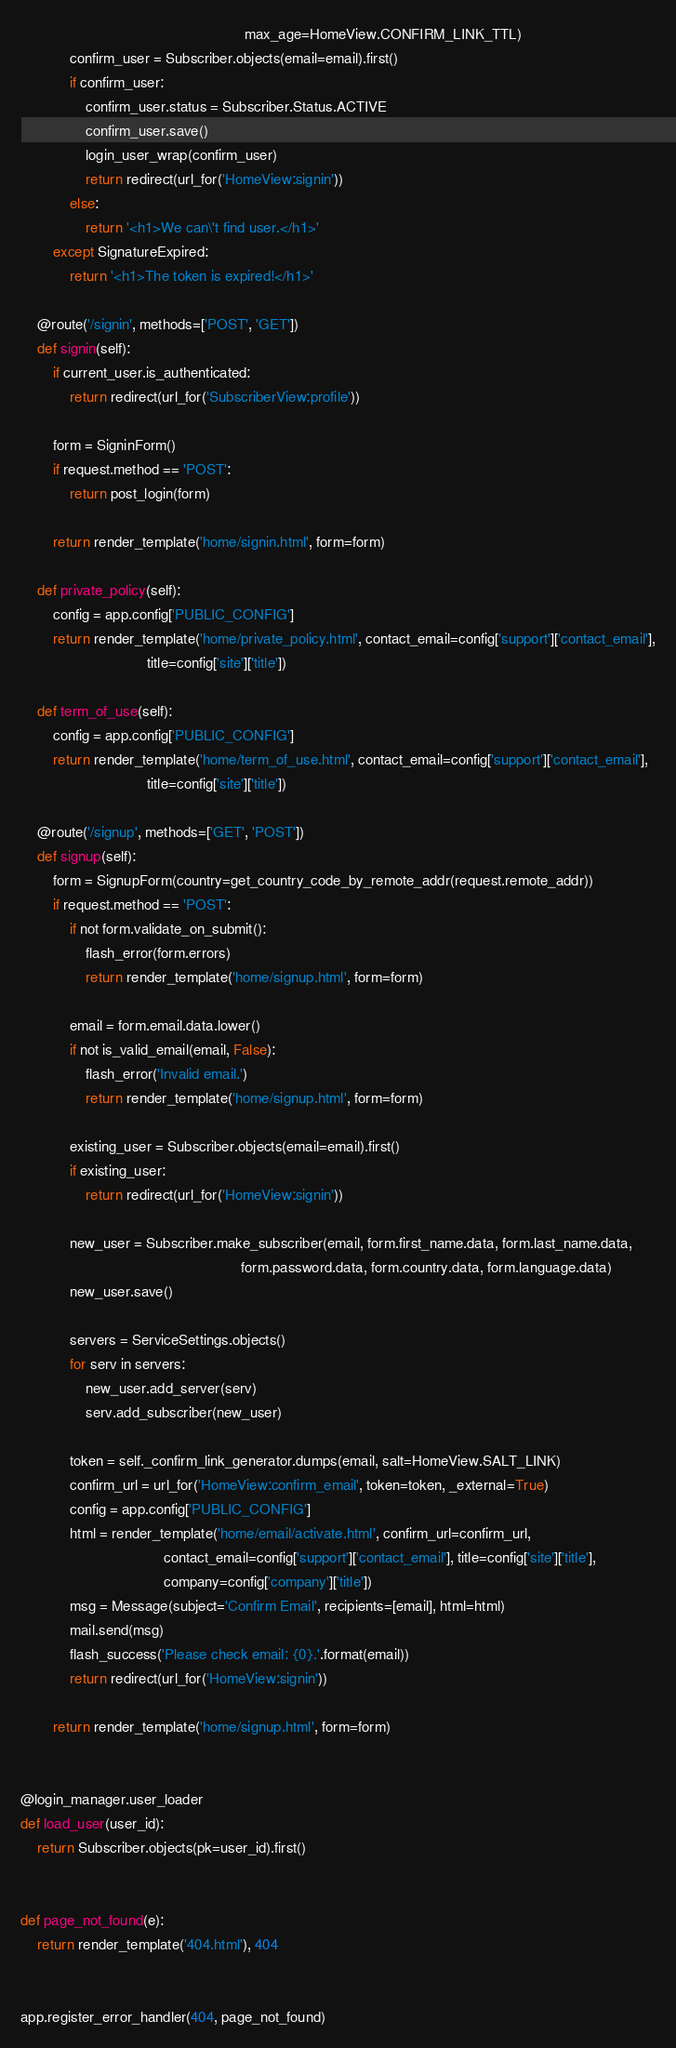<code> <loc_0><loc_0><loc_500><loc_500><_Python_>                                                       max_age=HomeView.CONFIRM_LINK_TTL)
            confirm_user = Subscriber.objects(email=email).first()
            if confirm_user:
                confirm_user.status = Subscriber.Status.ACTIVE
                confirm_user.save()
                login_user_wrap(confirm_user)
                return redirect(url_for('HomeView:signin'))
            else:
                return '<h1>We can\'t find user.</h1>'
        except SignatureExpired:
            return '<h1>The token is expired!</h1>'

    @route('/signin', methods=['POST', 'GET'])
    def signin(self):
        if current_user.is_authenticated:
            return redirect(url_for('SubscriberView:profile'))

        form = SigninForm()
        if request.method == 'POST':
            return post_login(form)

        return render_template('home/signin.html', form=form)

    def private_policy(self):
        config = app.config['PUBLIC_CONFIG']
        return render_template('home/private_policy.html', contact_email=config['support']['contact_email'],
                               title=config['site']['title'])

    def term_of_use(self):
        config = app.config['PUBLIC_CONFIG']
        return render_template('home/term_of_use.html', contact_email=config['support']['contact_email'],
                               title=config['site']['title'])

    @route('/signup', methods=['GET', 'POST'])
    def signup(self):
        form = SignupForm(country=get_country_code_by_remote_addr(request.remote_addr))
        if request.method == 'POST':
            if not form.validate_on_submit():
                flash_error(form.errors)
                return render_template('home/signup.html', form=form)

            email = form.email.data.lower()
            if not is_valid_email(email, False):
                flash_error('Invalid email.')
                return render_template('home/signup.html', form=form)

            existing_user = Subscriber.objects(email=email).first()
            if existing_user:
                return redirect(url_for('HomeView:signin'))

            new_user = Subscriber.make_subscriber(email, form.first_name.data, form.last_name.data,
                                                      form.password.data, form.country.data, form.language.data)
            new_user.save()

            servers = ServiceSettings.objects()
            for serv in servers:
                new_user.add_server(serv)
                serv.add_subscriber(new_user)

            token = self._confirm_link_generator.dumps(email, salt=HomeView.SALT_LINK)
            confirm_url = url_for('HomeView:confirm_email', token=token, _external=True)
            config = app.config['PUBLIC_CONFIG']
            html = render_template('home/email/activate.html', confirm_url=confirm_url,
                                   contact_email=config['support']['contact_email'], title=config['site']['title'],
                                   company=config['company']['title'])
            msg = Message(subject='Confirm Email', recipients=[email], html=html)
            mail.send(msg)
            flash_success('Please check email: {0}.'.format(email))
            return redirect(url_for('HomeView:signin'))

        return render_template('home/signup.html', form=form)


@login_manager.user_loader
def load_user(user_id):
    return Subscriber.objects(pk=user_id).first()


def page_not_found(e):
    return render_template('404.html'), 404


app.register_error_handler(404, page_not_found)
</code> 